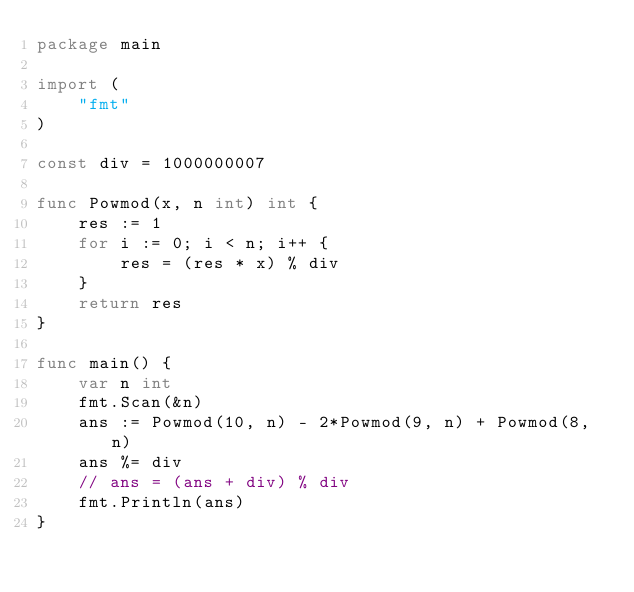<code> <loc_0><loc_0><loc_500><loc_500><_Go_>package main

import (
	"fmt"
)

const div = 1000000007

func Powmod(x, n int) int {
	res := 1
	for i := 0; i < n; i++ {
		res = (res * x) % div
	}
	return res
}

func main() {
	var n int
	fmt.Scan(&n)
	ans := Powmod(10, n) - 2*Powmod(9, n) + Powmod(8, n)
	ans %= div
	// ans = (ans + div) % div
	fmt.Println(ans)
}
</code> 